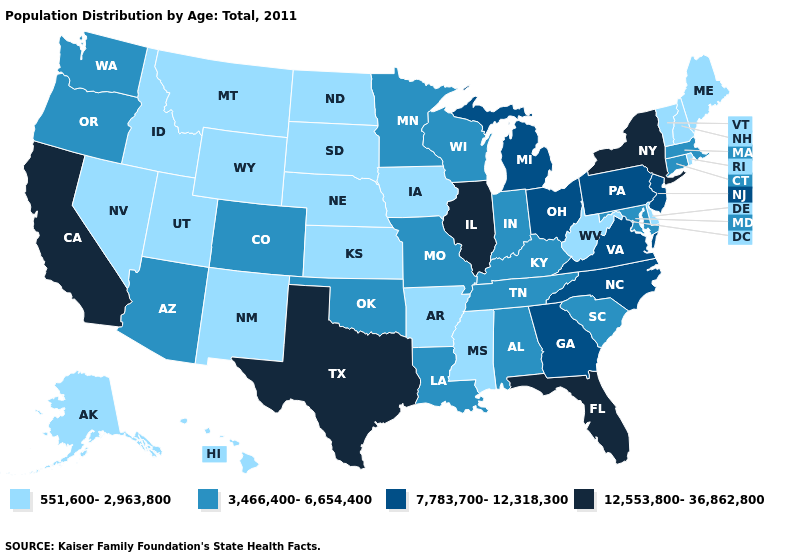Name the states that have a value in the range 12,553,800-36,862,800?
Keep it brief. California, Florida, Illinois, New York, Texas. What is the value of New Mexico?
Short answer required. 551,600-2,963,800. Does Illinois have the highest value in the USA?
Be succinct. Yes. What is the highest value in states that border Delaware?
Concise answer only. 7,783,700-12,318,300. What is the lowest value in the USA?
Short answer required. 551,600-2,963,800. Does Minnesota have a higher value than Washington?
Short answer required. No. Does Washington have a higher value than Alaska?
Give a very brief answer. Yes. Which states have the lowest value in the USA?
Give a very brief answer. Alaska, Arkansas, Delaware, Hawaii, Idaho, Iowa, Kansas, Maine, Mississippi, Montana, Nebraska, Nevada, New Hampshire, New Mexico, North Dakota, Rhode Island, South Dakota, Utah, Vermont, West Virginia, Wyoming. What is the value of Texas?
Answer briefly. 12,553,800-36,862,800. Does Colorado have the lowest value in the West?
Concise answer only. No. How many symbols are there in the legend?
Give a very brief answer. 4. Which states have the lowest value in the USA?
Concise answer only. Alaska, Arkansas, Delaware, Hawaii, Idaho, Iowa, Kansas, Maine, Mississippi, Montana, Nebraska, Nevada, New Hampshire, New Mexico, North Dakota, Rhode Island, South Dakota, Utah, Vermont, West Virginia, Wyoming. What is the highest value in the Northeast ?
Give a very brief answer. 12,553,800-36,862,800. Which states have the lowest value in the MidWest?
Write a very short answer. Iowa, Kansas, Nebraska, North Dakota, South Dakota. 